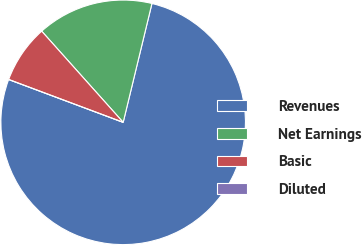<chart> <loc_0><loc_0><loc_500><loc_500><pie_chart><fcel>Revenues<fcel>Net Earnings<fcel>Basic<fcel>Diluted<nl><fcel>76.92%<fcel>15.39%<fcel>7.69%<fcel>0.0%<nl></chart> 